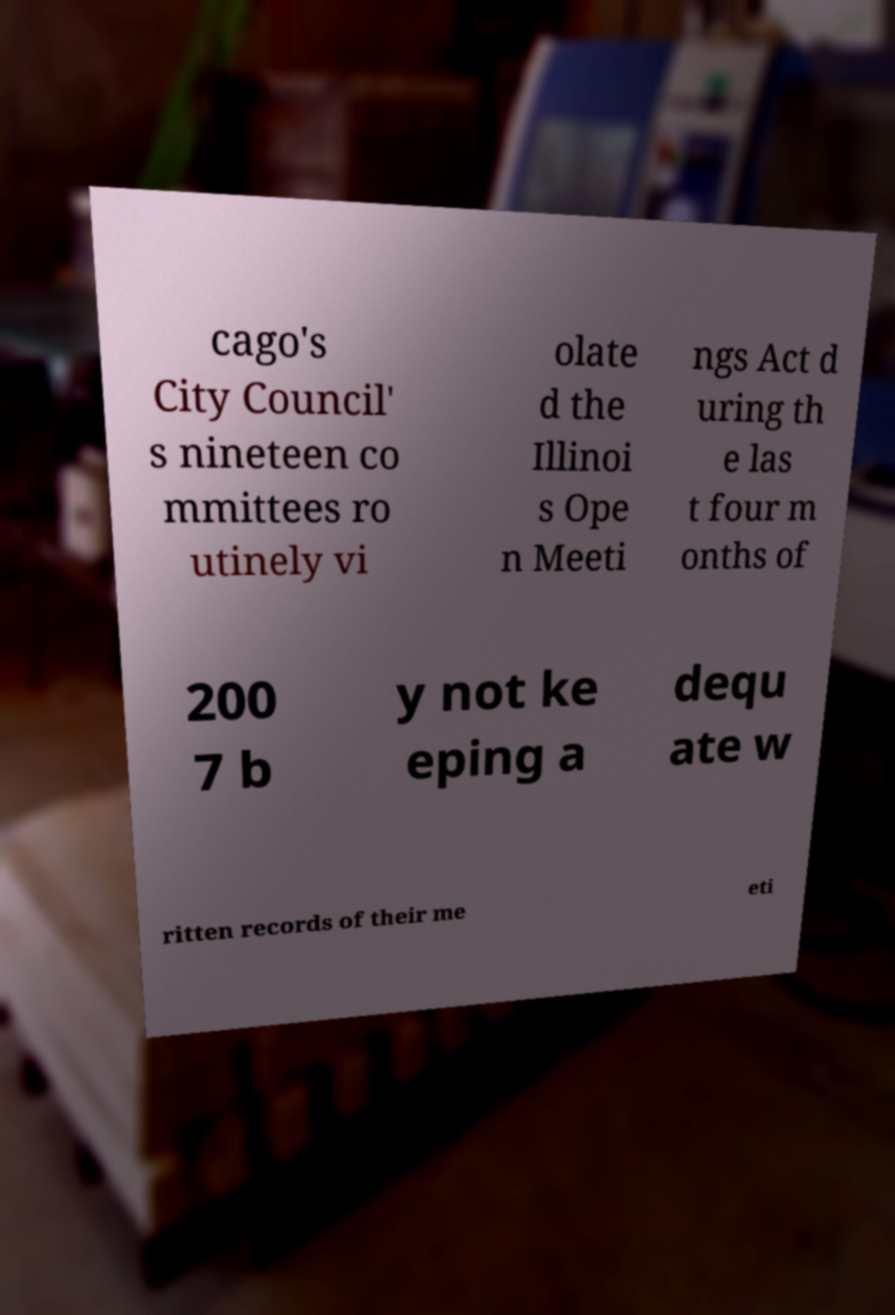There's text embedded in this image that I need extracted. Can you transcribe it verbatim? cago's City Council' s nineteen co mmittees ro utinely vi olate d the Illinoi s Ope n Meeti ngs Act d uring th e las t four m onths of 200 7 b y not ke eping a dequ ate w ritten records of their me eti 